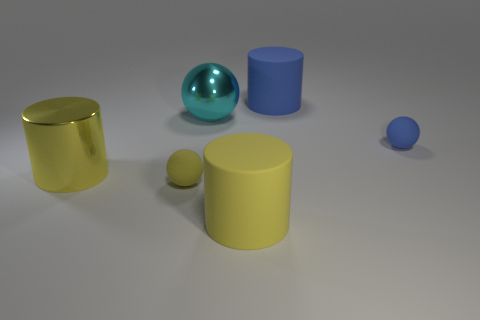There is a yellow metallic object; does it have the same shape as the metallic thing that is behind the big shiny cylinder?
Offer a terse response. No. What number of other objects are there of the same material as the large blue cylinder?
Keep it short and to the point. 3. There is a shiny sphere; is its color the same as the shiny object that is left of the cyan shiny object?
Provide a short and direct response. No. There is a small ball on the left side of the metal ball; what material is it?
Offer a very short reply. Rubber. Are there any tiny rubber things that have the same color as the metal cylinder?
Offer a terse response. Yes. There is another matte cylinder that is the same size as the blue cylinder; what is its color?
Offer a very short reply. Yellow. What number of large objects are either yellow shiny objects or yellow cylinders?
Make the answer very short. 2. Is the number of rubber cylinders in front of the blue cylinder the same as the number of yellow matte spheres on the right side of the small blue rubber object?
Your answer should be compact. No. How many shiny balls are the same size as the cyan thing?
Ensure brevity in your answer.  0. What number of blue objects are either matte cylinders or large spheres?
Give a very brief answer. 1. 